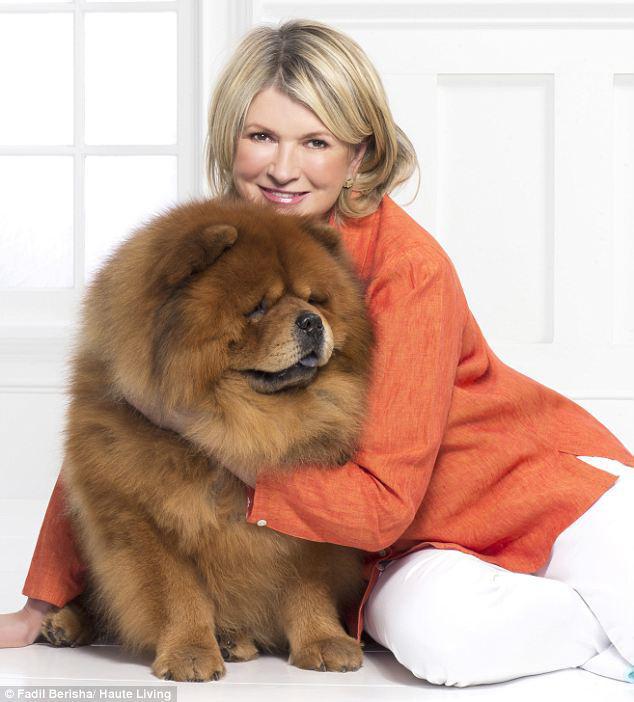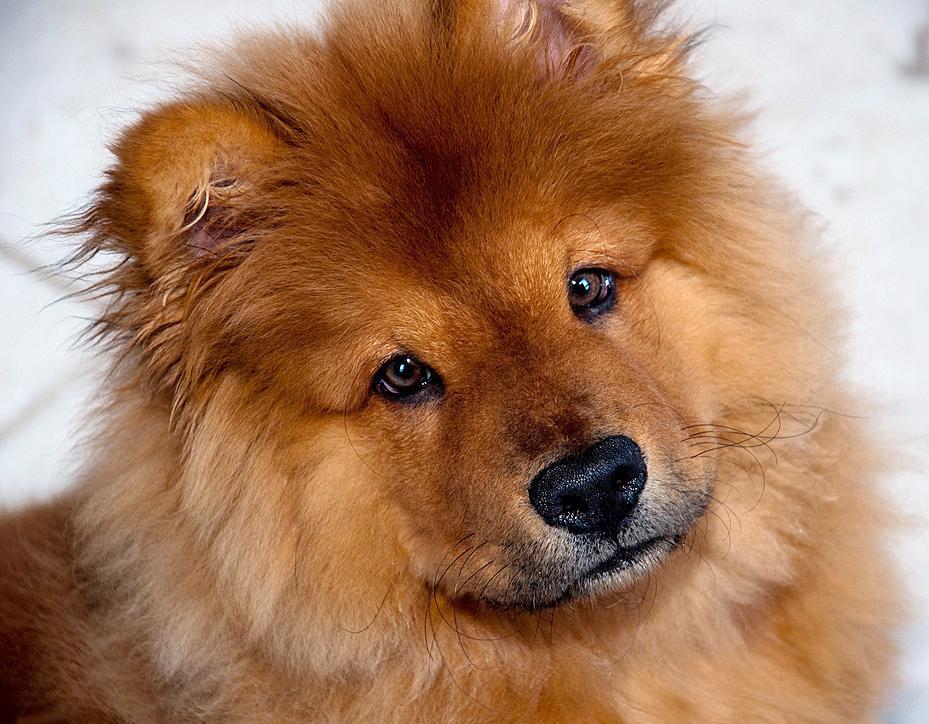The first image is the image on the left, the second image is the image on the right. For the images displayed, is the sentence "The pair of pictures shows exactly two dogs and no human." factually correct? Answer yes or no. No. The first image is the image on the left, the second image is the image on the right. Evaluate the accuracy of this statement regarding the images: "The left image contains a human holding a chow dog.". Is it true? Answer yes or no. Yes. 